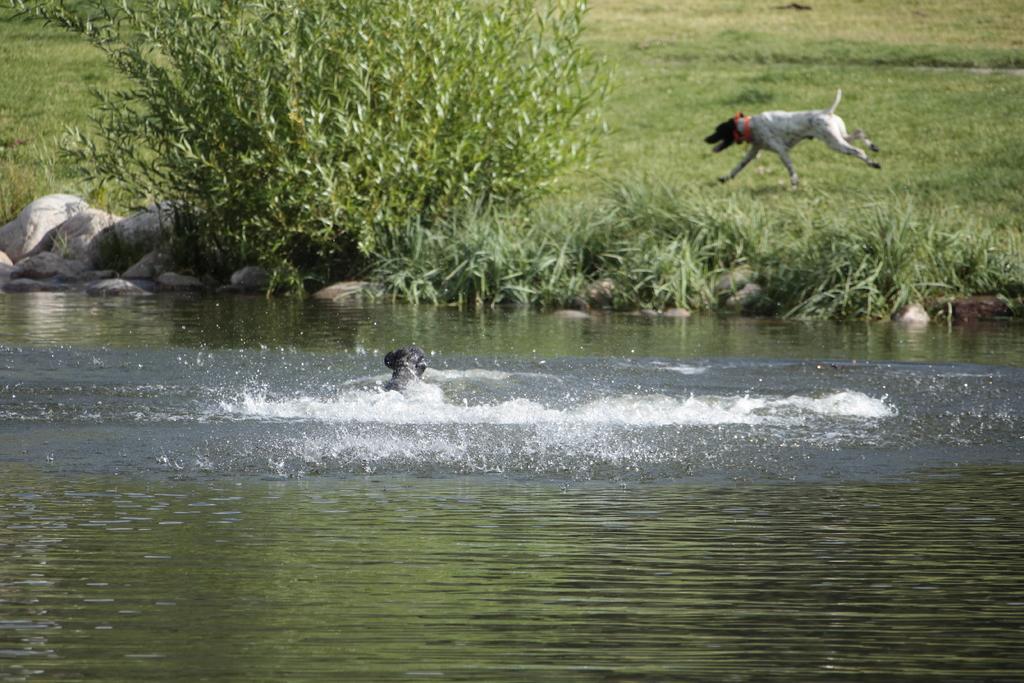In one or two sentences, can you explain what this image depicts? In this image there is an animal in the water, in front of the river there are few rocks, trees and a dog running on the surface of the grass. 